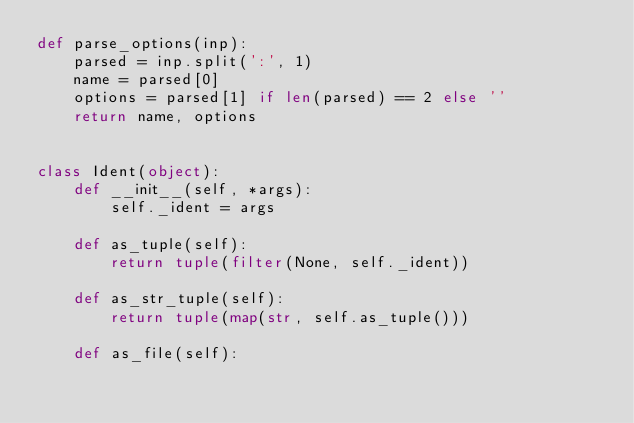<code> <loc_0><loc_0><loc_500><loc_500><_Python_>def parse_options(inp):
    parsed = inp.split(':', 1)
    name = parsed[0]
    options = parsed[1] if len(parsed) == 2 else ''
    return name, options


class Ident(object):
    def __init__(self, *args):
        self._ident = args

    def as_tuple(self):
        return tuple(filter(None, self._ident))

    def as_str_tuple(self):
        return tuple(map(str, self.as_tuple()))

    def as_file(self):</code> 